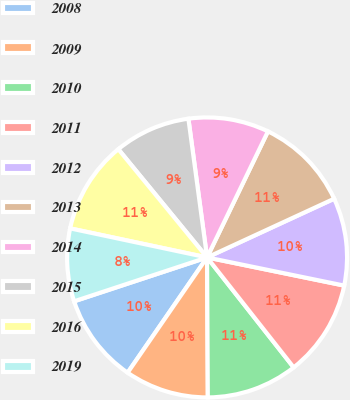Convert chart. <chart><loc_0><loc_0><loc_500><loc_500><pie_chart><fcel>2008<fcel>2009<fcel>2010<fcel>2011<fcel>2012<fcel>2013<fcel>2014<fcel>2015<fcel>2016<fcel>2019<nl><fcel>10.32%<fcel>9.69%<fcel>10.53%<fcel>11.16%<fcel>10.11%<fcel>10.95%<fcel>9.29%<fcel>8.8%<fcel>10.74%<fcel>8.4%<nl></chart> 